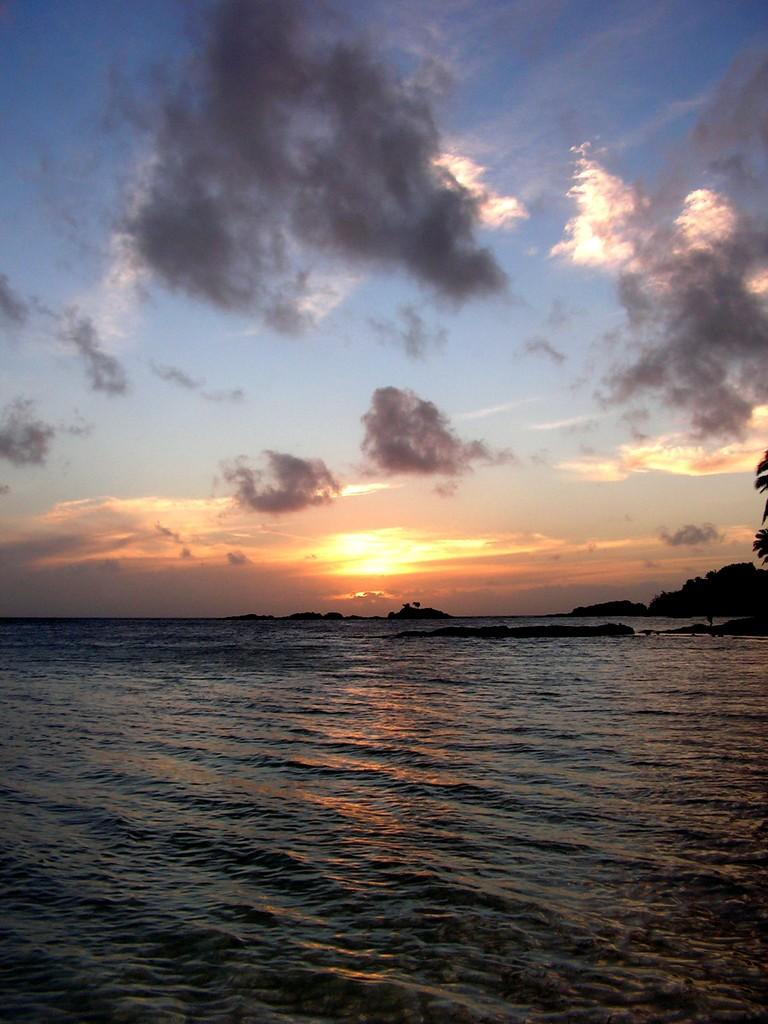What is visible in the image? Water is visible in the image. What type of natural landforms can be seen in the image? There are hills in the image. What is visible in the background of the image? There are clouds and the sun visible in the background of the image. What degree is the person in the image discussing with their peers? There is no person or discussion present in the image; it features water, hills, clouds, and the sun. How much dust can be seen blowing in the wind in the image? There is no dust visible in the image; it features water, hills, clouds, and the sun. 